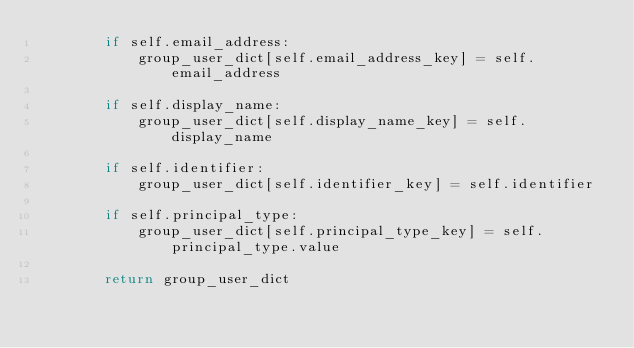Convert code to text. <code><loc_0><loc_0><loc_500><loc_500><_Python_>        if self.email_address:
            group_user_dict[self.email_address_key] = self.email_address

        if self.display_name:
            group_user_dict[self.display_name_key] = self.display_name

        if self.identifier:
            group_user_dict[self.identifier_key] = self.identifier

        if self.principal_type:
            group_user_dict[self.principal_type_key] = self.principal_type.value

        return group_user_dict
</code> 